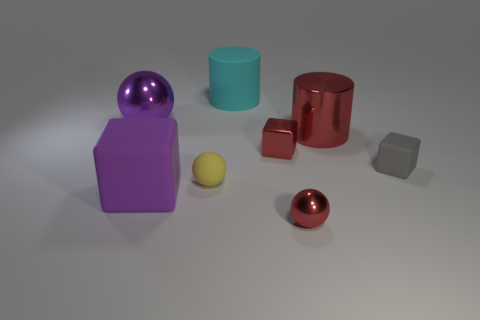There is a rubber sphere; does it have the same color as the tiny block that is behind the small gray object?
Provide a succinct answer. No. Is the number of tiny red metallic cubes that are right of the gray matte thing the same as the number of large cubes behind the purple shiny sphere?
Ensure brevity in your answer.  Yes. What number of big green things are the same shape as the tiny gray thing?
Your answer should be compact. 0. Are any big green metal things visible?
Your answer should be compact. No. Does the small gray thing have the same material as the tiny red object that is behind the tiny red ball?
Keep it short and to the point. No. There is a red object that is the same size as the red ball; what is its material?
Your answer should be very brief. Metal. Are there any cyan objects made of the same material as the gray object?
Provide a short and direct response. Yes. Are there any small shiny cubes in front of the small thing that is to the left of the big cylinder that is behind the big red cylinder?
Keep it short and to the point. No. There is a yellow rubber object that is the same size as the gray block; what shape is it?
Make the answer very short. Sphere. There is a metallic ball that is on the left side of the tiny red ball; does it have the same size as the matte thing right of the red metal cylinder?
Provide a short and direct response. No. 